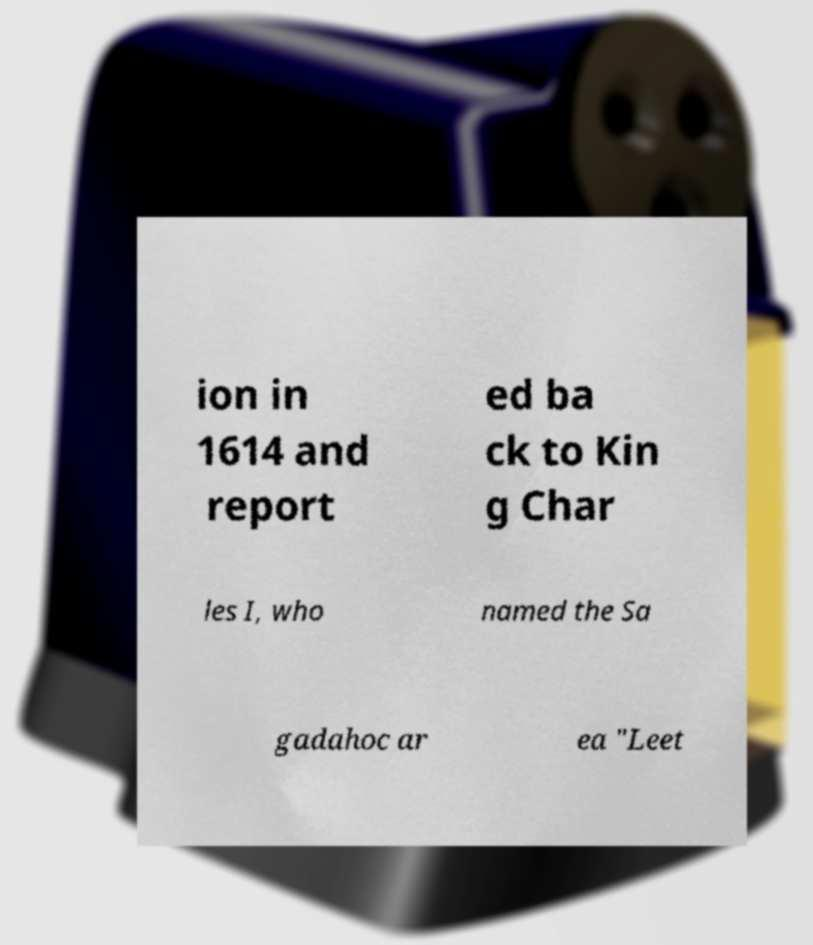There's text embedded in this image that I need extracted. Can you transcribe it verbatim? ion in 1614 and report ed ba ck to Kin g Char les I, who named the Sa gadahoc ar ea "Leet 